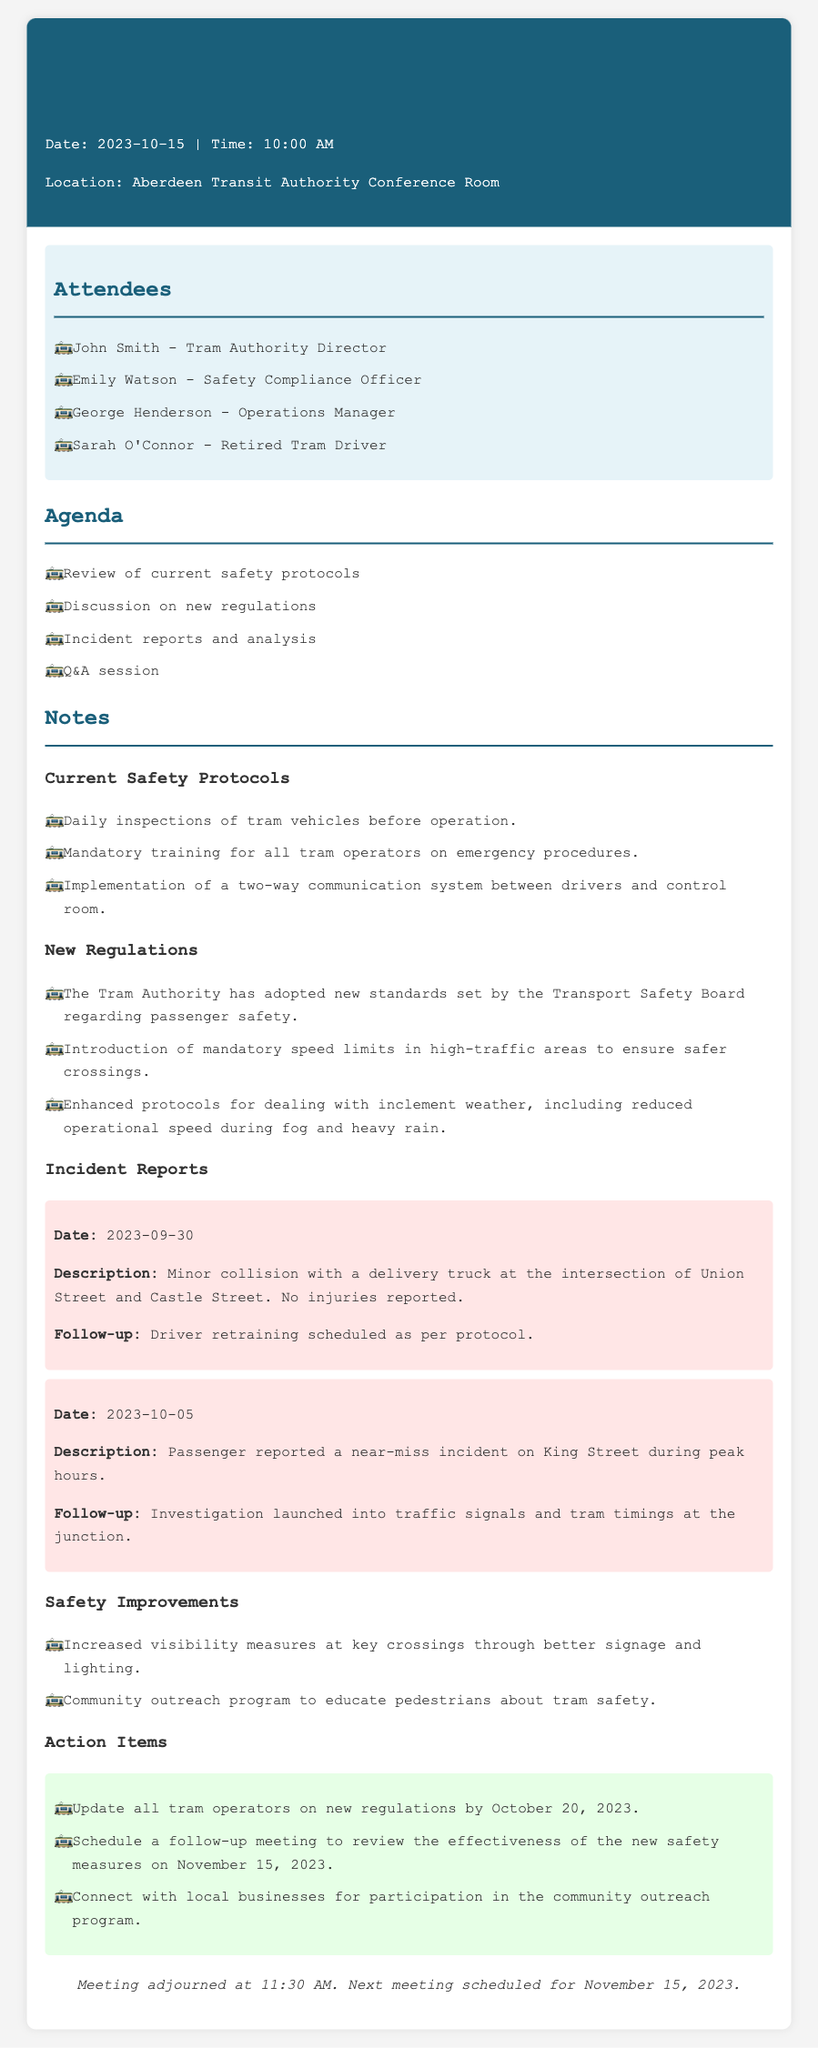What date was the meeting held? The date of the meeting is explicitly mentioned in the header of the document.
Answer: 2023-10-15 Who is the Safety Compliance Officer? The name of the Safety Compliance Officer is listed under the attendees section.
Answer: Emily Watson What is one of the new regulations mentioned? The document outlines specific new regulations in the notes section.
Answer: Mandatory speed limits What incident occurred on 2023-09-30? The specific details of the incident on that date are detailed in the incident reports section.
Answer: Minor collision with a delivery truck What is the follow-up action for the incident on 2023-10-05? The follow-up actions for each incident are provided in the incident reports.
Answer: Investigation launched How many attendees were present at the meeting? The number of attendees is found in the attendees section of the document.
Answer: Four What is one of the safety improvements mentioned? The safety improvements are summarized in a section dedicated to that topic within the notes.
Answer: Increased visibility measures What is the date for the next scheduled meeting? The date for the next meeting is mentioned in the closing remarks of the document.
Answer: November 15, 2023 